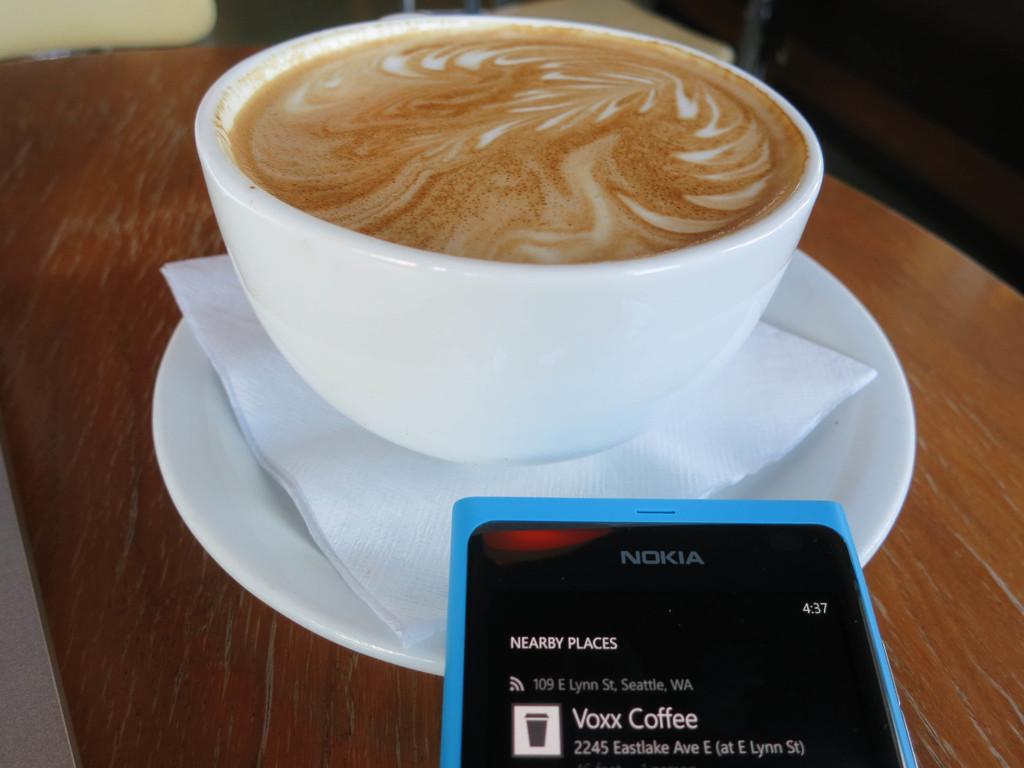How would you summarize this image in a sentence or two? In this picture we can see a table,on this table we can see a saucer,tissue paper,mobile and a cup with coffee in it. 